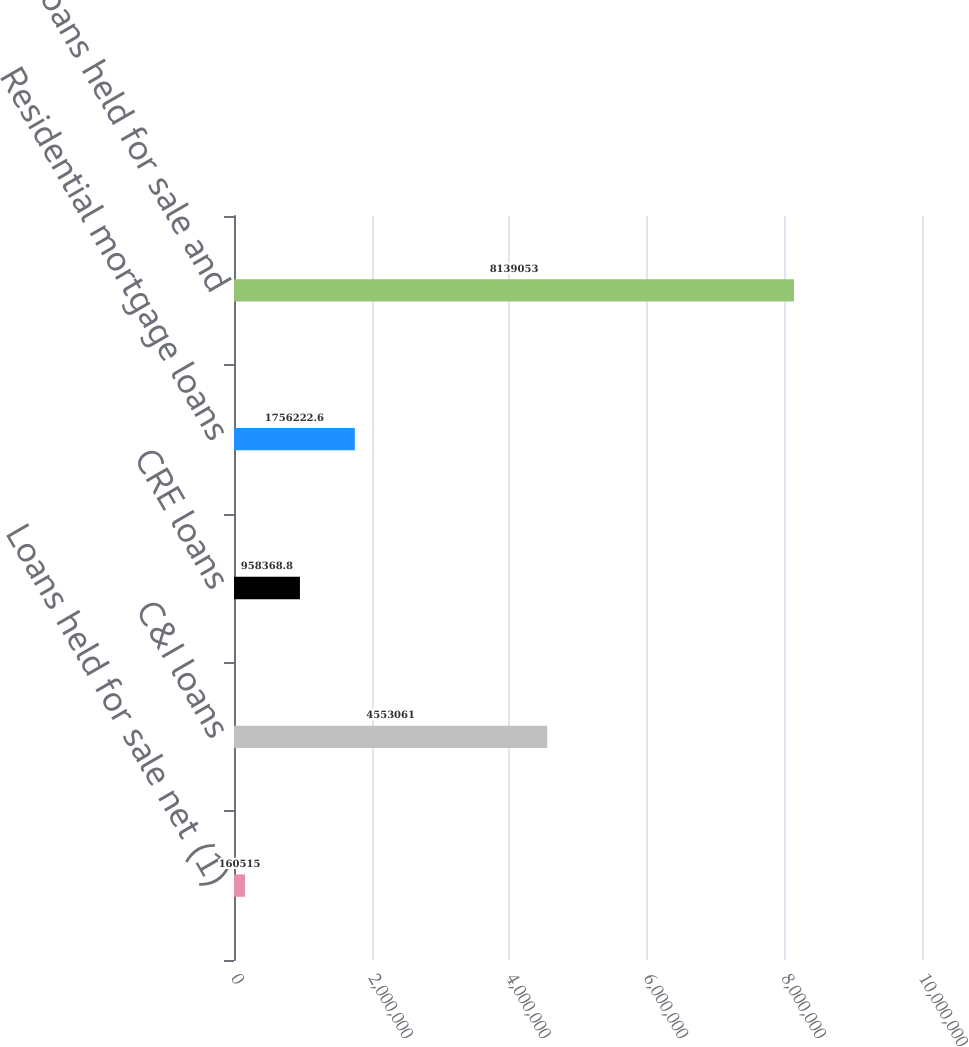Convert chart. <chart><loc_0><loc_0><loc_500><loc_500><bar_chart><fcel>Loans held for sale net (1)<fcel>C&I loans<fcel>CRE loans<fcel>Residential mortgage loans<fcel>Total loans held for sale and<nl><fcel>160515<fcel>4.55306e+06<fcel>958369<fcel>1.75622e+06<fcel>8.13905e+06<nl></chart> 